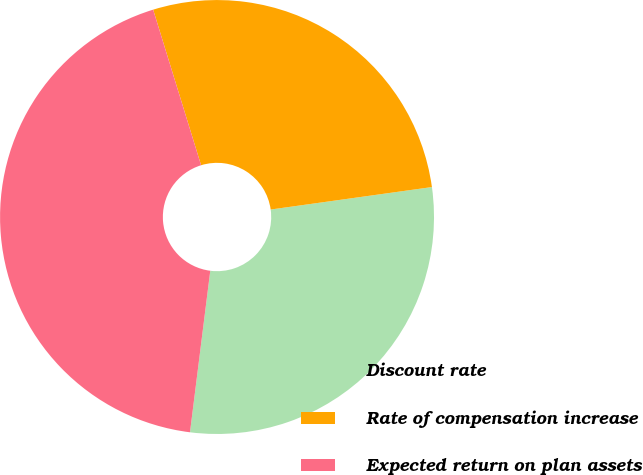Convert chart to OTSL. <chart><loc_0><loc_0><loc_500><loc_500><pie_chart><fcel>Discount rate<fcel>Rate of compensation increase<fcel>Expected return on plan assets<nl><fcel>29.19%<fcel>27.55%<fcel>43.25%<nl></chart> 